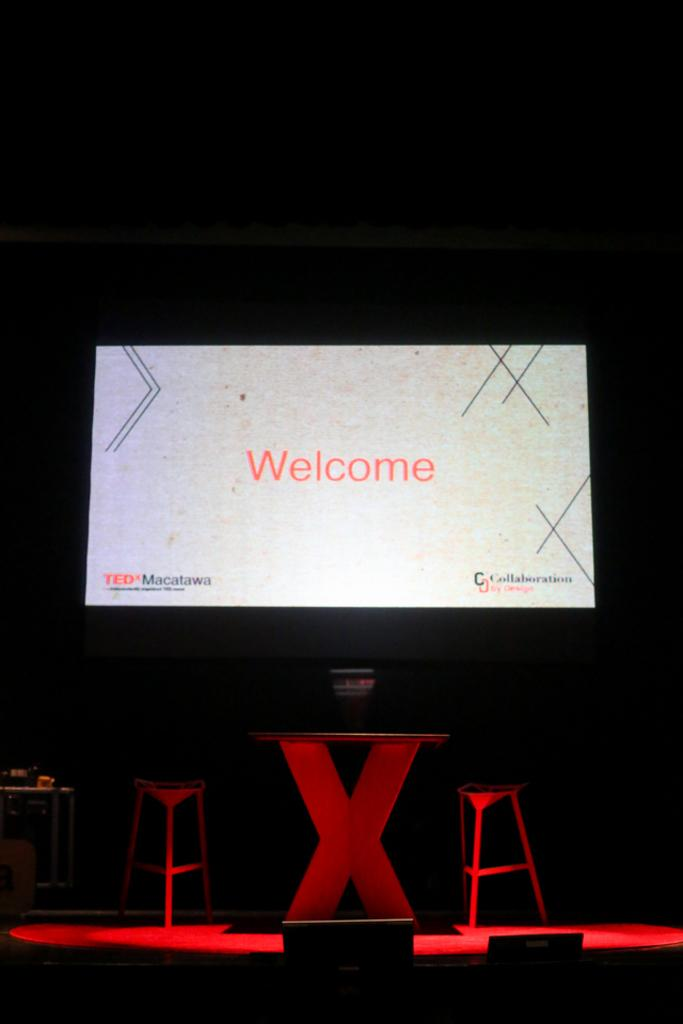<image>
Present a compact description of the photo's key features. On a dark spotlit stage a large screen is welcoming those who see it. 